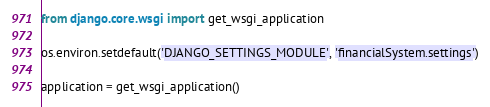Convert code to text. <code><loc_0><loc_0><loc_500><loc_500><_Python_>from django.core.wsgi import get_wsgi_application

os.environ.setdefault('DJANGO_SETTINGS_MODULE', 'financialSystem.settings')

application = get_wsgi_application()
</code> 